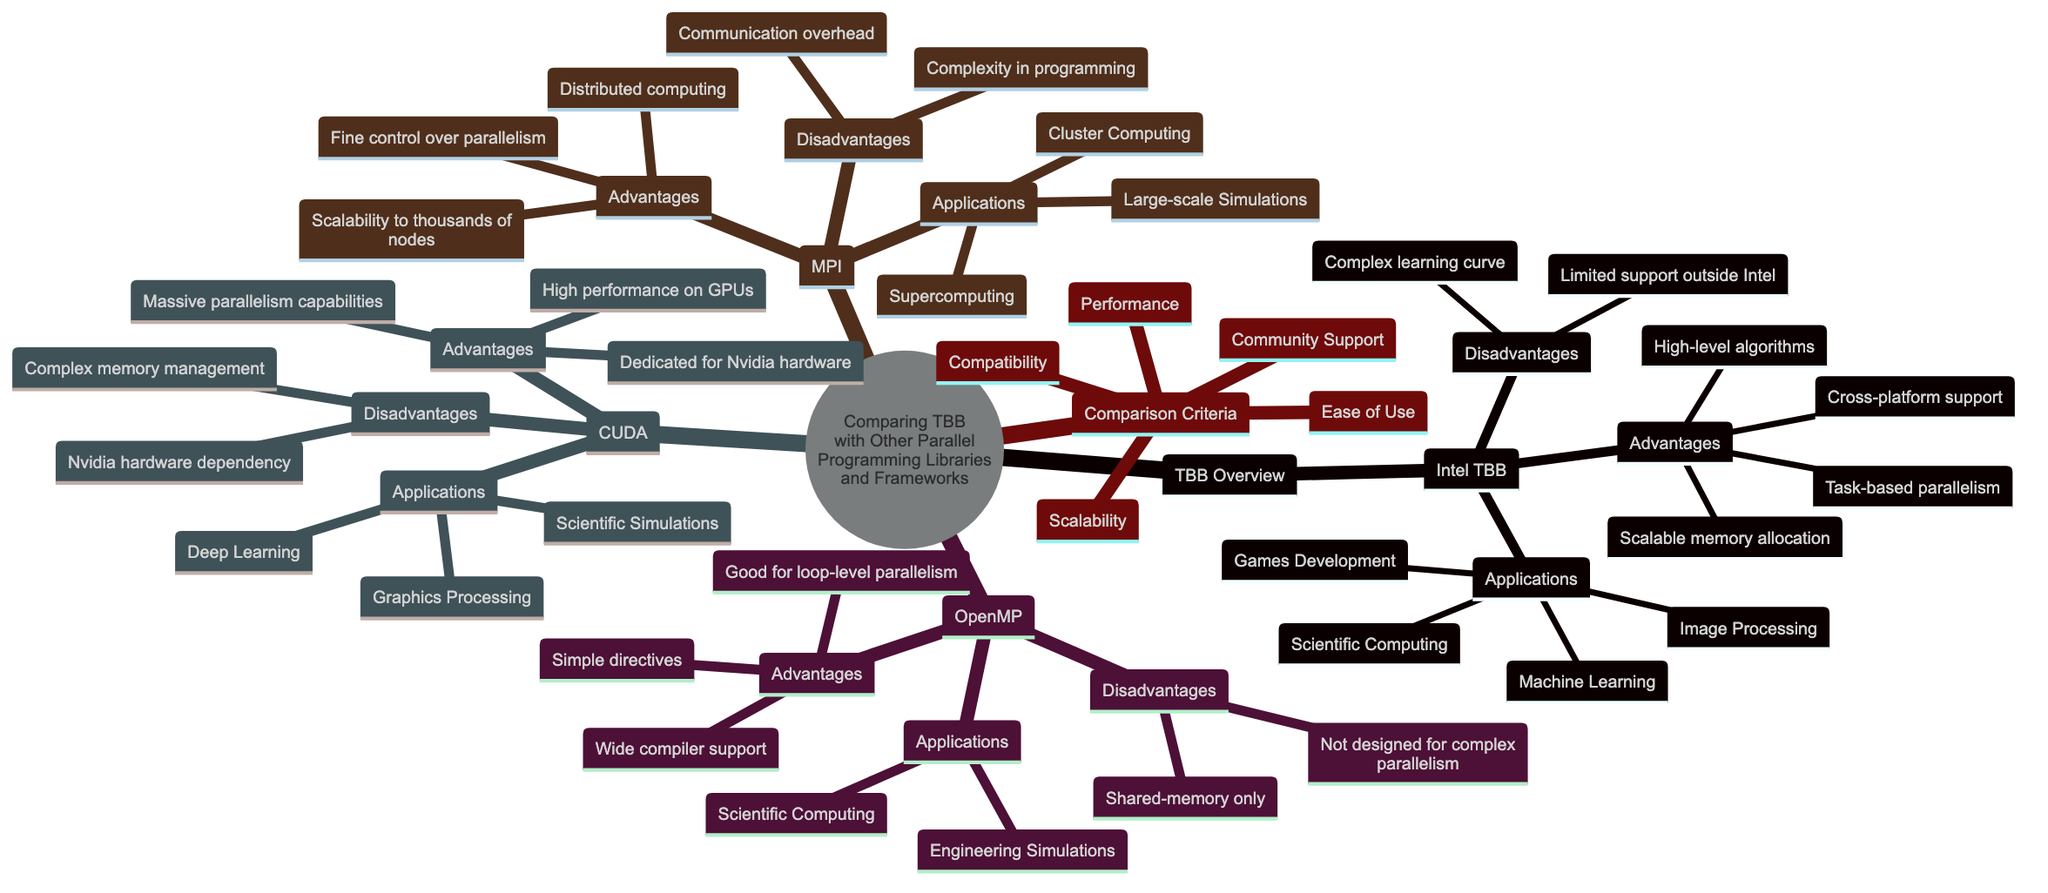What are the main advantages of Intel TBB? The advantages of Intel TBB can be found directly in the subnode labeled "Advantages" under "Intel TBB." They include task-based parallelism, scalable memory allocation, cross-platform support, and high-level algorithms.
Answer: Task-based parallelism, scalable memory allocation, cross-platform support, high-level algorithms How many disadvantages does OpenMP have? The "Disadvantages" subnode under "OpenMP" lists two items, indicating the total number of disadvantages.
Answer: 2 What is one application of CUDA? The "Applications" subnode under "CUDA" lists three fields, one of which can be chosen as an example. The options are deep learning, graphics processing, and scientific simulations.
Answer: Deep Learning Which parallel programming library/framework has the highest scalability? "MPI" has the advantage of scalability in the node labeled "Advantages," where it mentions scalability to thousands of nodes, indicating that it is designed for distributed computing.
Answer: MPI How many nodes are there in the "Comparison Criteria"? The "Comparison Criteria" contains five subnodes that list different aspects to compare among the libraries, indicating the total number of criteria.
Answer: 5 What is a disadvantage of Intel TBB? The "Disadvantages" subnode for Intel TBB includes two items: complex learning curve and limited support outside Intel. Both items indicate the drawbacks of using TBB.
Answer: Complex learning curve Which framework is dedicated to Nvidia hardware? Under the "Advantages" of the "CUDA" node, it is specified that CUDA is dedicated to Nvidia hardware; this means it is specifically designed to operate with that hardware.
Answer: CUDA What is the primary focus of OpenMP? The advantages of OpenMP suggest its focus on implementing simple directives for parallelism, especially good for loop-level operations.
Answer: Loop-level parallelism 